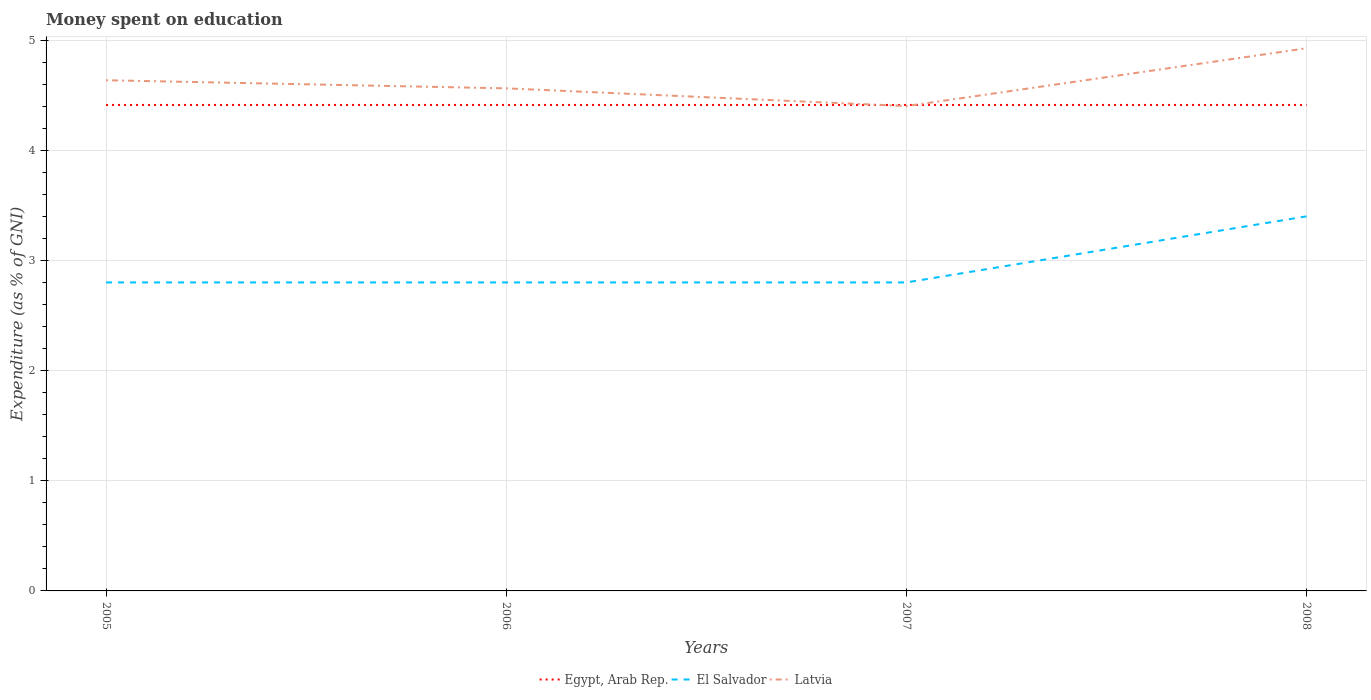Does the line corresponding to El Salvador intersect with the line corresponding to Egypt, Arab Rep.?
Provide a succinct answer. No. Is the number of lines equal to the number of legend labels?
Your answer should be very brief. Yes. Across all years, what is the maximum amount of money spent on education in Latvia?
Ensure brevity in your answer.  4.4. What is the total amount of money spent on education in El Salvador in the graph?
Provide a succinct answer. -0.6. What is the difference between the highest and the second highest amount of money spent on education in El Salvador?
Provide a succinct answer. 0.6. What is the difference between the highest and the lowest amount of money spent on education in Egypt, Arab Rep.?
Offer a terse response. 0. What is the difference between two consecutive major ticks on the Y-axis?
Keep it short and to the point. 1. How are the legend labels stacked?
Ensure brevity in your answer.  Horizontal. What is the title of the graph?
Your answer should be compact. Money spent on education. Does "Papua New Guinea" appear as one of the legend labels in the graph?
Offer a very short reply. No. What is the label or title of the Y-axis?
Offer a terse response. Expenditure (as % of GNI). What is the Expenditure (as % of GNI) in Egypt, Arab Rep. in 2005?
Your answer should be compact. 4.41. What is the Expenditure (as % of GNI) in Latvia in 2005?
Offer a terse response. 4.64. What is the Expenditure (as % of GNI) of Egypt, Arab Rep. in 2006?
Your answer should be very brief. 4.41. What is the Expenditure (as % of GNI) in El Salvador in 2006?
Provide a short and direct response. 2.8. What is the Expenditure (as % of GNI) in Latvia in 2006?
Your answer should be very brief. 4.56. What is the Expenditure (as % of GNI) of Egypt, Arab Rep. in 2007?
Ensure brevity in your answer.  4.41. What is the Expenditure (as % of GNI) in El Salvador in 2007?
Give a very brief answer. 2.8. What is the Expenditure (as % of GNI) of Latvia in 2007?
Make the answer very short. 4.4. What is the Expenditure (as % of GNI) in Egypt, Arab Rep. in 2008?
Your answer should be compact. 4.41. What is the Expenditure (as % of GNI) of El Salvador in 2008?
Provide a succinct answer. 3.4. What is the Expenditure (as % of GNI) of Latvia in 2008?
Offer a very short reply. 4.93. Across all years, what is the maximum Expenditure (as % of GNI) in Egypt, Arab Rep.?
Offer a terse response. 4.41. Across all years, what is the maximum Expenditure (as % of GNI) in Latvia?
Ensure brevity in your answer.  4.93. Across all years, what is the minimum Expenditure (as % of GNI) in Egypt, Arab Rep.?
Your answer should be very brief. 4.41. Across all years, what is the minimum Expenditure (as % of GNI) in El Salvador?
Provide a short and direct response. 2.8. Across all years, what is the minimum Expenditure (as % of GNI) in Latvia?
Ensure brevity in your answer.  4.4. What is the total Expenditure (as % of GNI) of Egypt, Arab Rep. in the graph?
Provide a short and direct response. 17.64. What is the total Expenditure (as % of GNI) of El Salvador in the graph?
Make the answer very short. 11.8. What is the total Expenditure (as % of GNI) of Latvia in the graph?
Offer a very short reply. 18.52. What is the difference between the Expenditure (as % of GNI) of Latvia in 2005 and that in 2006?
Your answer should be very brief. 0.07. What is the difference between the Expenditure (as % of GNI) in Egypt, Arab Rep. in 2005 and that in 2007?
Ensure brevity in your answer.  0. What is the difference between the Expenditure (as % of GNI) in El Salvador in 2005 and that in 2007?
Keep it short and to the point. 0. What is the difference between the Expenditure (as % of GNI) of Latvia in 2005 and that in 2007?
Provide a short and direct response. 0.23. What is the difference between the Expenditure (as % of GNI) in Latvia in 2005 and that in 2008?
Your response must be concise. -0.29. What is the difference between the Expenditure (as % of GNI) in Latvia in 2006 and that in 2007?
Provide a short and direct response. 0.16. What is the difference between the Expenditure (as % of GNI) of Egypt, Arab Rep. in 2006 and that in 2008?
Your answer should be very brief. 0. What is the difference between the Expenditure (as % of GNI) in El Salvador in 2006 and that in 2008?
Offer a terse response. -0.6. What is the difference between the Expenditure (as % of GNI) in Latvia in 2006 and that in 2008?
Offer a very short reply. -0.36. What is the difference between the Expenditure (as % of GNI) of Egypt, Arab Rep. in 2007 and that in 2008?
Keep it short and to the point. 0. What is the difference between the Expenditure (as % of GNI) in El Salvador in 2007 and that in 2008?
Your answer should be compact. -0.6. What is the difference between the Expenditure (as % of GNI) of Latvia in 2007 and that in 2008?
Offer a terse response. -0.52. What is the difference between the Expenditure (as % of GNI) in Egypt, Arab Rep. in 2005 and the Expenditure (as % of GNI) in El Salvador in 2006?
Offer a very short reply. 1.61. What is the difference between the Expenditure (as % of GNI) of Egypt, Arab Rep. in 2005 and the Expenditure (as % of GNI) of Latvia in 2006?
Keep it short and to the point. -0.15. What is the difference between the Expenditure (as % of GNI) of El Salvador in 2005 and the Expenditure (as % of GNI) of Latvia in 2006?
Give a very brief answer. -1.76. What is the difference between the Expenditure (as % of GNI) in Egypt, Arab Rep. in 2005 and the Expenditure (as % of GNI) in El Salvador in 2007?
Your answer should be compact. 1.61. What is the difference between the Expenditure (as % of GNI) of Egypt, Arab Rep. in 2005 and the Expenditure (as % of GNI) of Latvia in 2007?
Ensure brevity in your answer.  0.01. What is the difference between the Expenditure (as % of GNI) of El Salvador in 2005 and the Expenditure (as % of GNI) of Latvia in 2007?
Make the answer very short. -1.6. What is the difference between the Expenditure (as % of GNI) of Egypt, Arab Rep. in 2005 and the Expenditure (as % of GNI) of El Salvador in 2008?
Provide a succinct answer. 1.01. What is the difference between the Expenditure (as % of GNI) of Egypt, Arab Rep. in 2005 and the Expenditure (as % of GNI) of Latvia in 2008?
Your answer should be very brief. -0.51. What is the difference between the Expenditure (as % of GNI) in El Salvador in 2005 and the Expenditure (as % of GNI) in Latvia in 2008?
Your answer should be very brief. -2.13. What is the difference between the Expenditure (as % of GNI) of Egypt, Arab Rep. in 2006 and the Expenditure (as % of GNI) of El Salvador in 2007?
Ensure brevity in your answer.  1.61. What is the difference between the Expenditure (as % of GNI) of Egypt, Arab Rep. in 2006 and the Expenditure (as % of GNI) of Latvia in 2007?
Your answer should be compact. 0.01. What is the difference between the Expenditure (as % of GNI) in El Salvador in 2006 and the Expenditure (as % of GNI) in Latvia in 2007?
Ensure brevity in your answer.  -1.6. What is the difference between the Expenditure (as % of GNI) in Egypt, Arab Rep. in 2006 and the Expenditure (as % of GNI) in El Salvador in 2008?
Offer a terse response. 1.01. What is the difference between the Expenditure (as % of GNI) in Egypt, Arab Rep. in 2006 and the Expenditure (as % of GNI) in Latvia in 2008?
Make the answer very short. -0.51. What is the difference between the Expenditure (as % of GNI) of El Salvador in 2006 and the Expenditure (as % of GNI) of Latvia in 2008?
Your response must be concise. -2.13. What is the difference between the Expenditure (as % of GNI) of Egypt, Arab Rep. in 2007 and the Expenditure (as % of GNI) of El Salvador in 2008?
Your answer should be very brief. 1.01. What is the difference between the Expenditure (as % of GNI) in Egypt, Arab Rep. in 2007 and the Expenditure (as % of GNI) in Latvia in 2008?
Your answer should be very brief. -0.51. What is the difference between the Expenditure (as % of GNI) in El Salvador in 2007 and the Expenditure (as % of GNI) in Latvia in 2008?
Provide a succinct answer. -2.13. What is the average Expenditure (as % of GNI) in Egypt, Arab Rep. per year?
Your response must be concise. 4.41. What is the average Expenditure (as % of GNI) in El Salvador per year?
Make the answer very short. 2.95. What is the average Expenditure (as % of GNI) of Latvia per year?
Provide a succinct answer. 4.63. In the year 2005, what is the difference between the Expenditure (as % of GNI) in Egypt, Arab Rep. and Expenditure (as % of GNI) in El Salvador?
Provide a succinct answer. 1.61. In the year 2005, what is the difference between the Expenditure (as % of GNI) in Egypt, Arab Rep. and Expenditure (as % of GNI) in Latvia?
Provide a succinct answer. -0.22. In the year 2005, what is the difference between the Expenditure (as % of GNI) in El Salvador and Expenditure (as % of GNI) in Latvia?
Offer a terse response. -1.84. In the year 2006, what is the difference between the Expenditure (as % of GNI) of Egypt, Arab Rep. and Expenditure (as % of GNI) of El Salvador?
Make the answer very short. 1.61. In the year 2006, what is the difference between the Expenditure (as % of GNI) of Egypt, Arab Rep. and Expenditure (as % of GNI) of Latvia?
Give a very brief answer. -0.15. In the year 2006, what is the difference between the Expenditure (as % of GNI) of El Salvador and Expenditure (as % of GNI) of Latvia?
Ensure brevity in your answer.  -1.76. In the year 2007, what is the difference between the Expenditure (as % of GNI) of Egypt, Arab Rep. and Expenditure (as % of GNI) of El Salvador?
Make the answer very short. 1.61. In the year 2007, what is the difference between the Expenditure (as % of GNI) in Egypt, Arab Rep. and Expenditure (as % of GNI) in Latvia?
Offer a terse response. 0.01. In the year 2007, what is the difference between the Expenditure (as % of GNI) of El Salvador and Expenditure (as % of GNI) of Latvia?
Provide a short and direct response. -1.6. In the year 2008, what is the difference between the Expenditure (as % of GNI) in Egypt, Arab Rep. and Expenditure (as % of GNI) in El Salvador?
Offer a very short reply. 1.01. In the year 2008, what is the difference between the Expenditure (as % of GNI) of Egypt, Arab Rep. and Expenditure (as % of GNI) of Latvia?
Give a very brief answer. -0.51. In the year 2008, what is the difference between the Expenditure (as % of GNI) in El Salvador and Expenditure (as % of GNI) in Latvia?
Give a very brief answer. -1.53. What is the ratio of the Expenditure (as % of GNI) in El Salvador in 2005 to that in 2006?
Make the answer very short. 1. What is the ratio of the Expenditure (as % of GNI) of Latvia in 2005 to that in 2006?
Offer a very short reply. 1.02. What is the ratio of the Expenditure (as % of GNI) in Egypt, Arab Rep. in 2005 to that in 2007?
Keep it short and to the point. 1. What is the ratio of the Expenditure (as % of GNI) of Latvia in 2005 to that in 2007?
Provide a succinct answer. 1.05. What is the ratio of the Expenditure (as % of GNI) in Egypt, Arab Rep. in 2005 to that in 2008?
Your response must be concise. 1. What is the ratio of the Expenditure (as % of GNI) of El Salvador in 2005 to that in 2008?
Your answer should be very brief. 0.82. What is the ratio of the Expenditure (as % of GNI) in Latvia in 2005 to that in 2008?
Provide a short and direct response. 0.94. What is the ratio of the Expenditure (as % of GNI) of El Salvador in 2006 to that in 2007?
Your response must be concise. 1. What is the ratio of the Expenditure (as % of GNI) in Latvia in 2006 to that in 2007?
Offer a very short reply. 1.04. What is the ratio of the Expenditure (as % of GNI) of El Salvador in 2006 to that in 2008?
Offer a terse response. 0.82. What is the ratio of the Expenditure (as % of GNI) in Latvia in 2006 to that in 2008?
Provide a succinct answer. 0.93. What is the ratio of the Expenditure (as % of GNI) in Egypt, Arab Rep. in 2007 to that in 2008?
Offer a very short reply. 1. What is the ratio of the Expenditure (as % of GNI) of El Salvador in 2007 to that in 2008?
Your response must be concise. 0.82. What is the ratio of the Expenditure (as % of GNI) in Latvia in 2007 to that in 2008?
Offer a very short reply. 0.89. What is the difference between the highest and the second highest Expenditure (as % of GNI) of Egypt, Arab Rep.?
Provide a succinct answer. 0. What is the difference between the highest and the second highest Expenditure (as % of GNI) of El Salvador?
Ensure brevity in your answer.  0.6. What is the difference between the highest and the second highest Expenditure (as % of GNI) of Latvia?
Offer a terse response. 0.29. What is the difference between the highest and the lowest Expenditure (as % of GNI) of El Salvador?
Ensure brevity in your answer.  0.6. What is the difference between the highest and the lowest Expenditure (as % of GNI) in Latvia?
Offer a terse response. 0.52. 